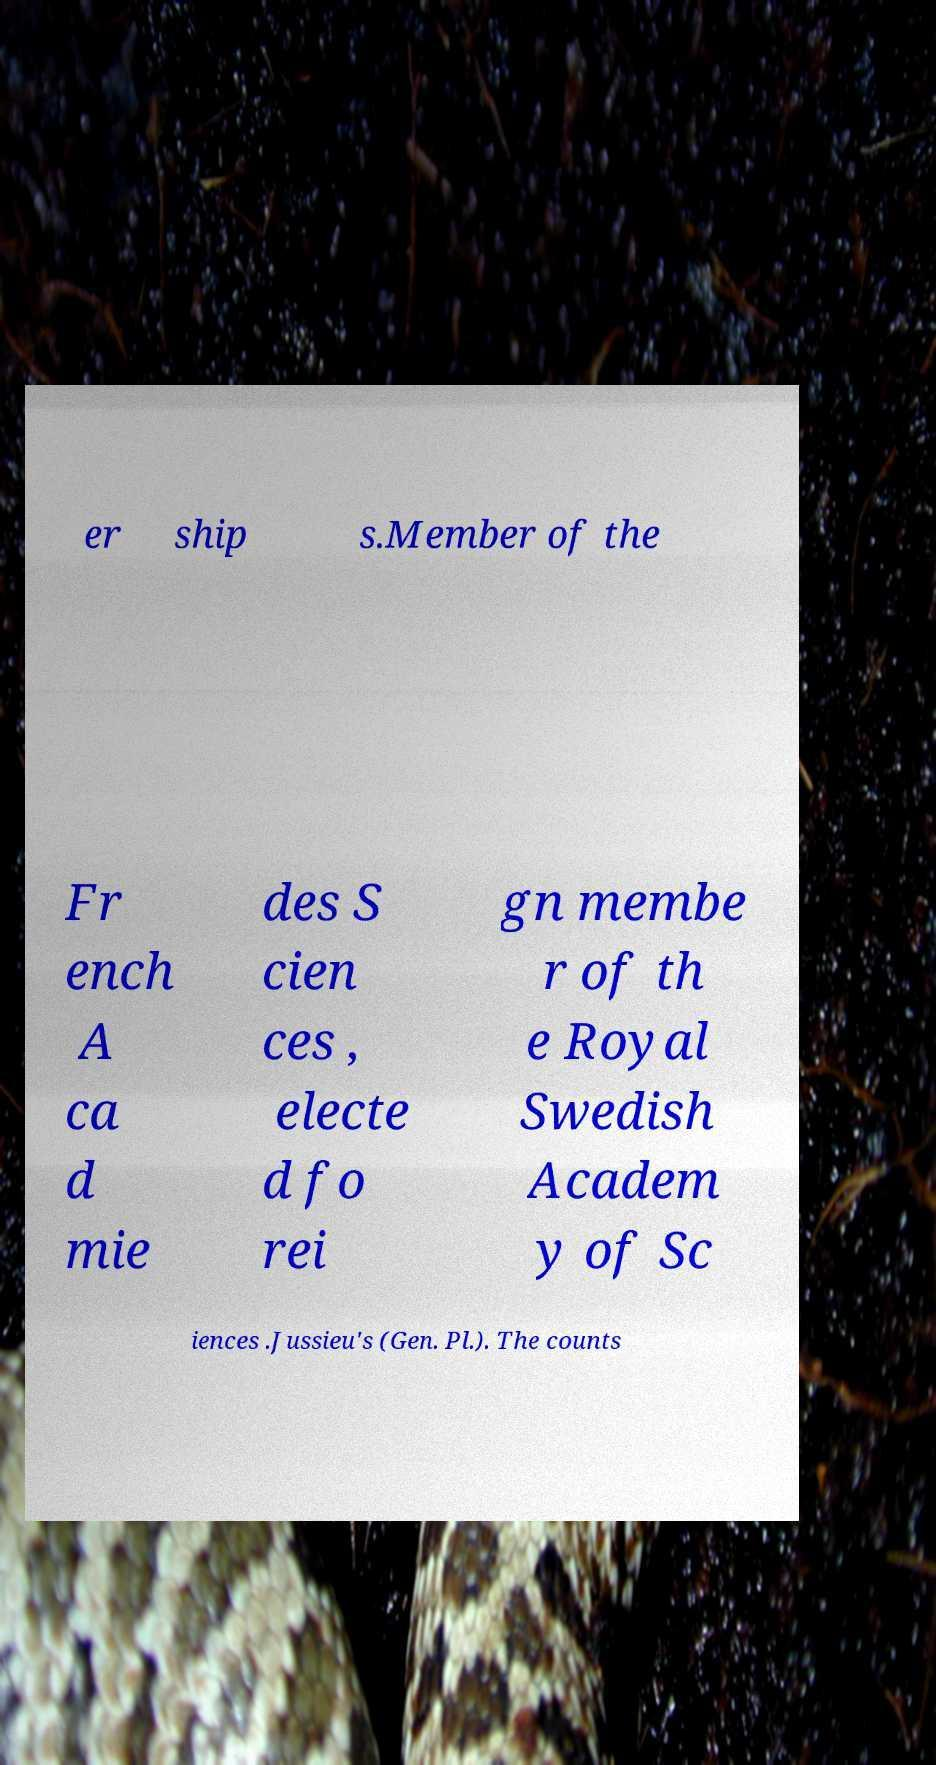For documentation purposes, I need the text within this image transcribed. Could you provide that? er ship s.Member of the Fr ench A ca d mie des S cien ces , electe d fo rei gn membe r of th e Royal Swedish Academ y of Sc iences .Jussieu's (Gen. Pl.). The counts 